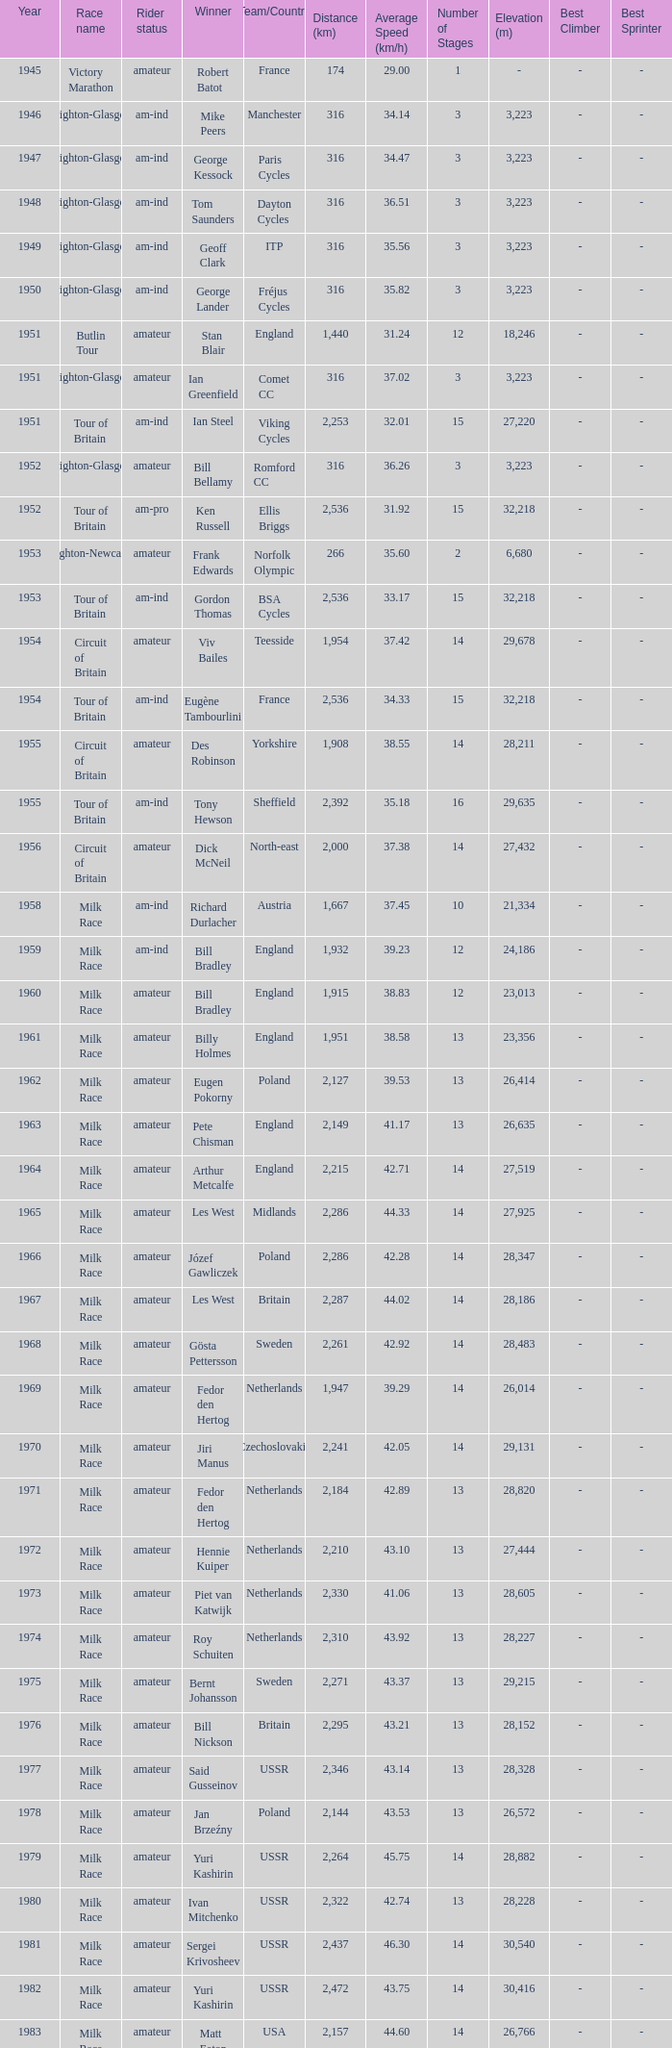What ream played later than 1958 in the kellogg's tour? ANC, Fagor, Z-Peugeot, Weinnmann-SMM, Motorola, Motorola, Motorola, Lampre. 